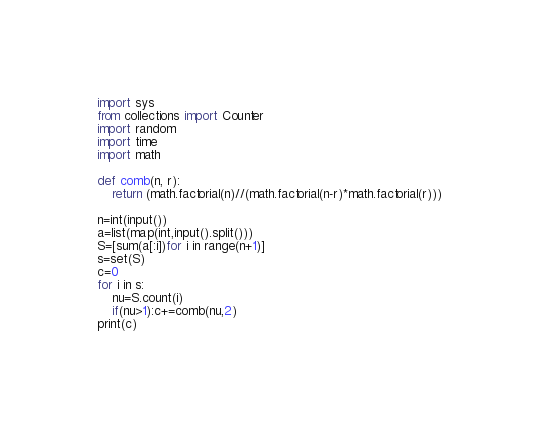<code> <loc_0><loc_0><loc_500><loc_500><_Python_>import sys
from collections import Counter
import random
import time
import math

def comb(n, r):
    return (math.factorial(n)//(math.factorial(n-r)*math.factorial(r)))

n=int(input())
a=list(map(int,input().split()))
S=[sum(a[:i])for i in range(n+1)]
s=set(S)
c=0
for i in s:
    nu=S.count(i)
    if(nu>1):c+=comb(nu,2)
print(c)</code> 